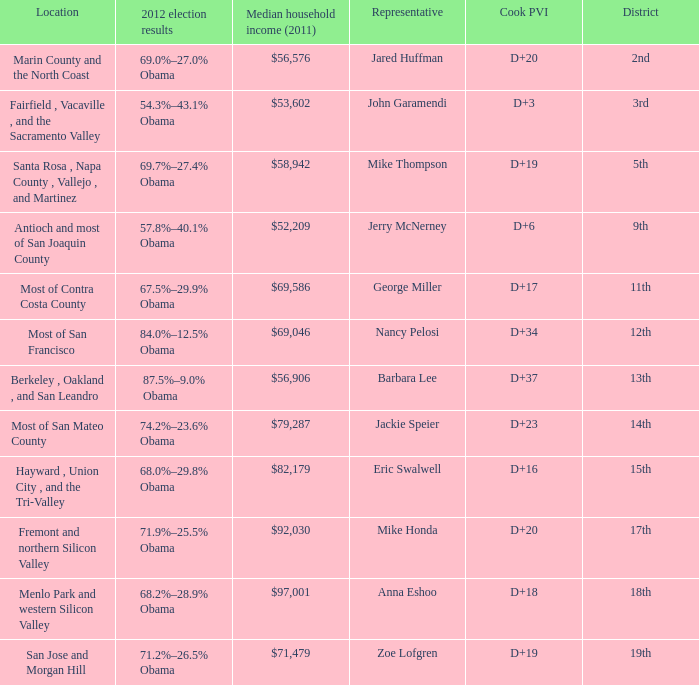What is the 2012 election results for locations whose representative is Barbara Lee? 87.5%–9.0% Obama. 